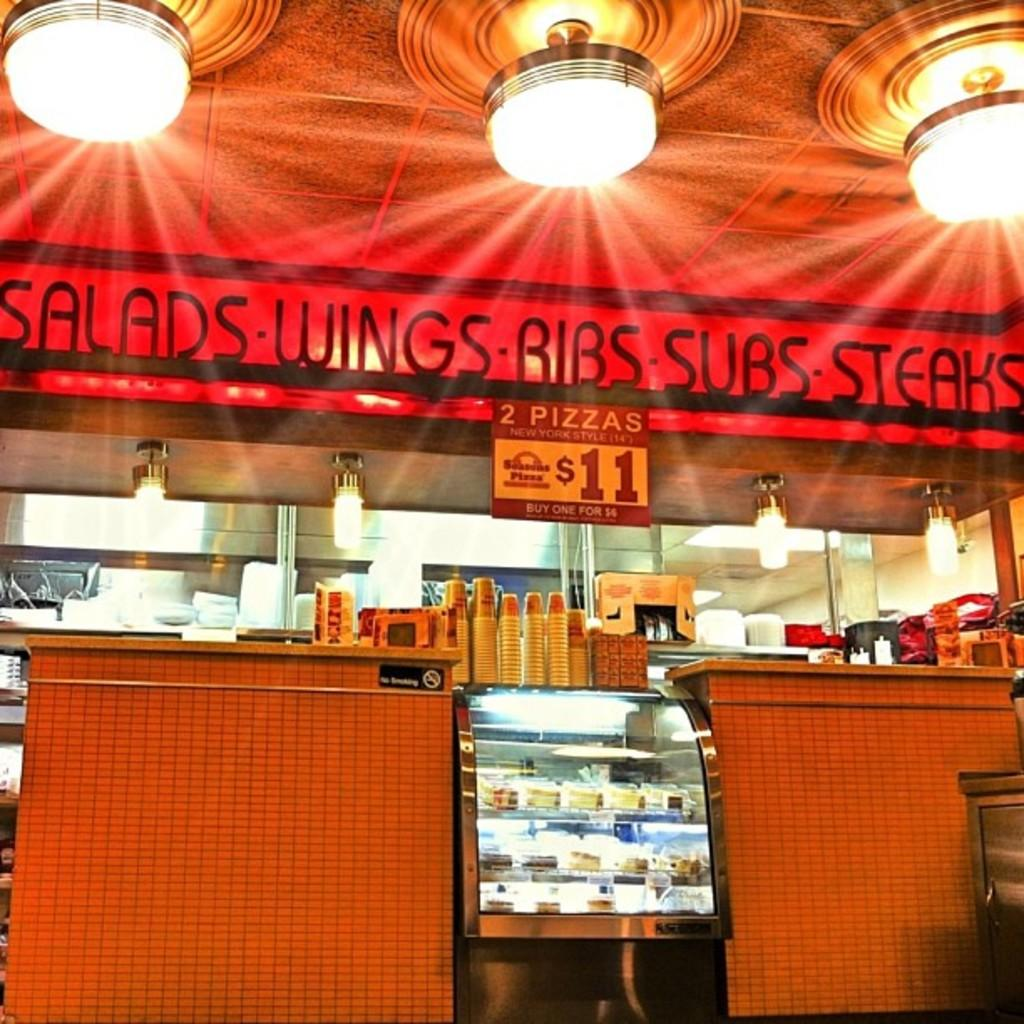<image>
Summarize the visual content of the image. Salads, Wings, Ribs, Subs and steaks are advertised in this small outlet. 